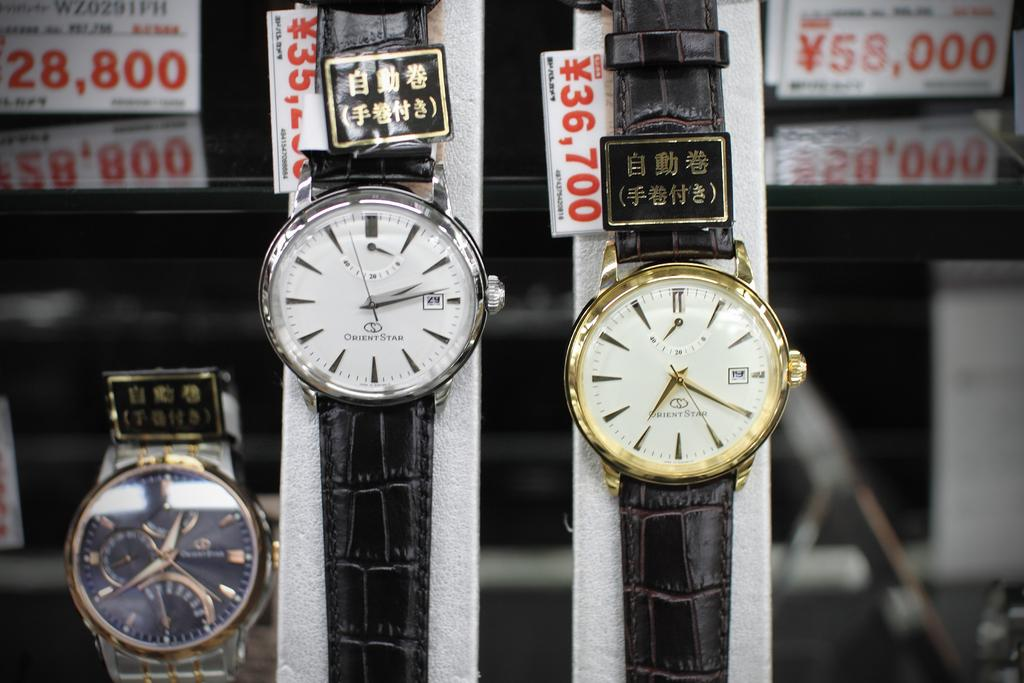What type of item is featured in the image? There are watches in the image. What color are the belts of the watches? The watches have black color belts. Are there any additional details about the watches in the image? Yes, there are price tags on the watches. What color are the price tags? The price tags are in red color. Can you see any fairies holding forks in the image? No, there are no fairies or forks present in the image. 